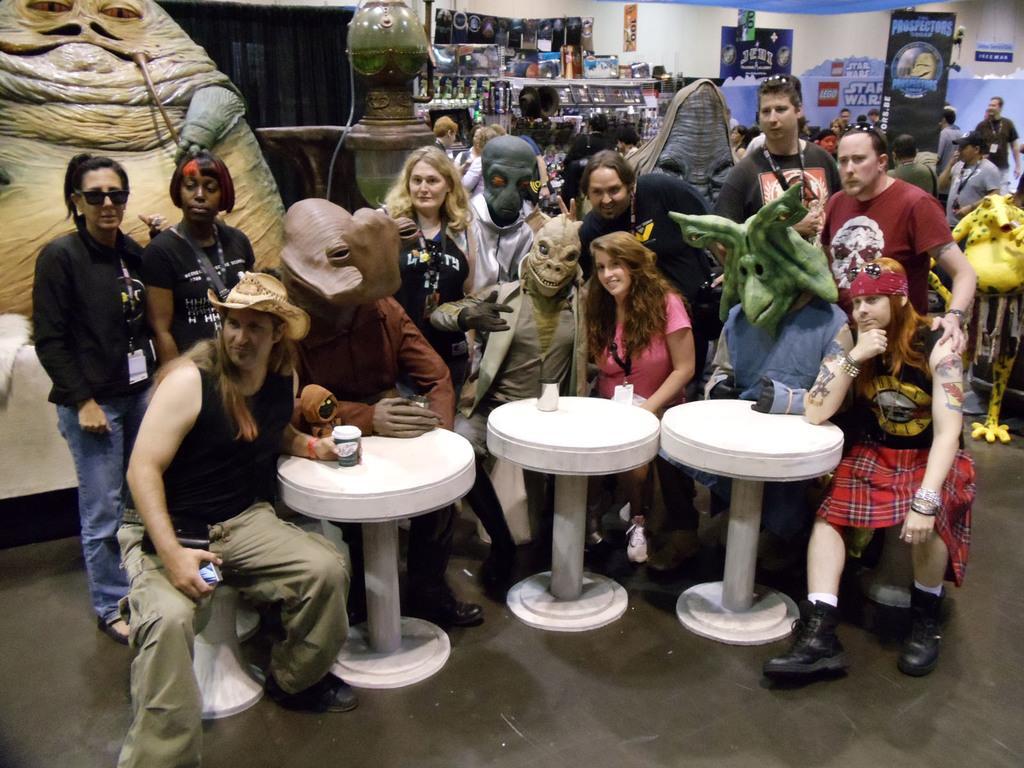Please provide a concise description of this image. Here we can see a few people who are posing for a photo. In the background we can see a group of people. 